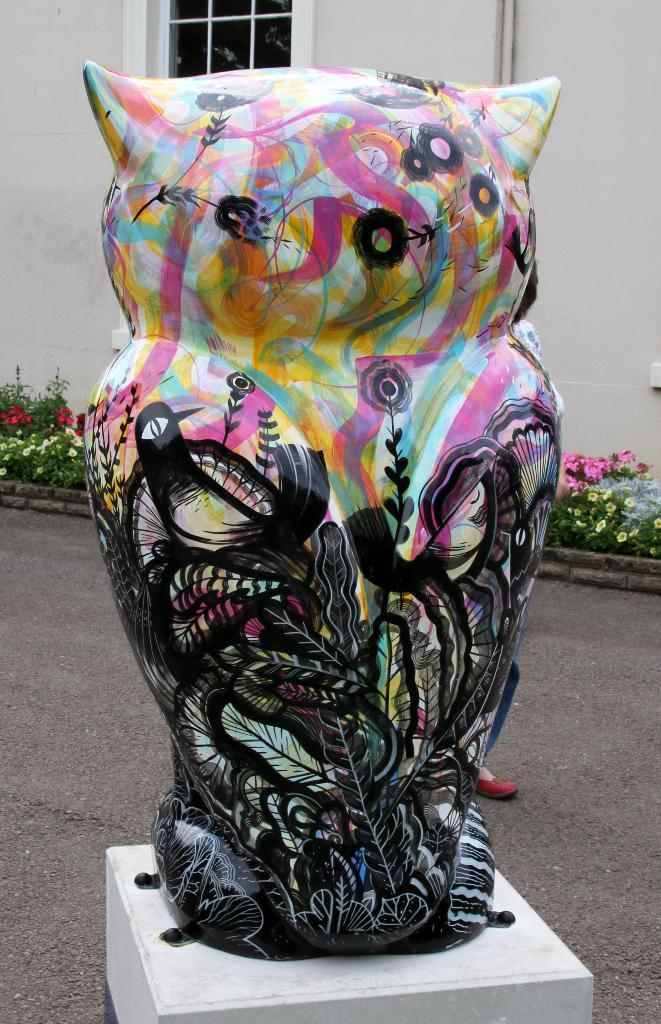What is the primary subject matter of the image? The image contains many plants. Are there any other objects or structures in the image? Yes, there is a sculpture in the image. How is the sculpture positioned in the image? The sculpture is placed on an object. What can be seen in the background of the image? There is a house in the background of the image. What type of acoustics can be heard in the image? There is no information about sounds or acoustics in the image, as it primarily features plants and a sculpture. 